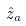<formula> <loc_0><loc_0><loc_500><loc_500>\hat { z } _ { a }</formula> 